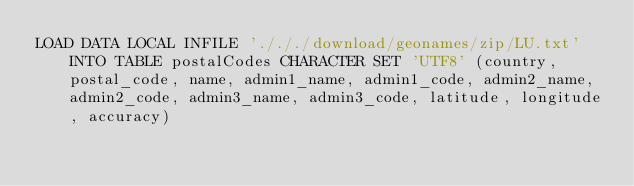Convert code to text. <code><loc_0><loc_0><loc_500><loc_500><_SQL_>LOAD DATA LOCAL INFILE './././download/geonames/zip/LU.txt' INTO TABLE postalCodes CHARACTER SET 'UTF8' (country, postal_code, name, admin1_name, admin1_code, admin2_name, admin2_code, admin3_name, admin3_code, latitude, longitude, accuracy)
</code> 